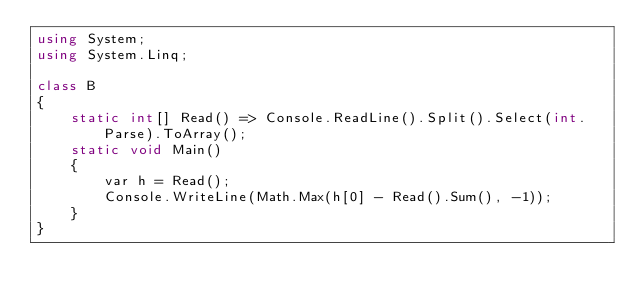Convert code to text. <code><loc_0><loc_0><loc_500><loc_500><_C#_>using System;
using System.Linq;

class B
{
	static int[] Read() => Console.ReadLine().Split().Select(int.Parse).ToArray();
	static void Main()
	{
		var h = Read();
		Console.WriteLine(Math.Max(h[0] - Read().Sum(), -1));
	}
}
</code> 